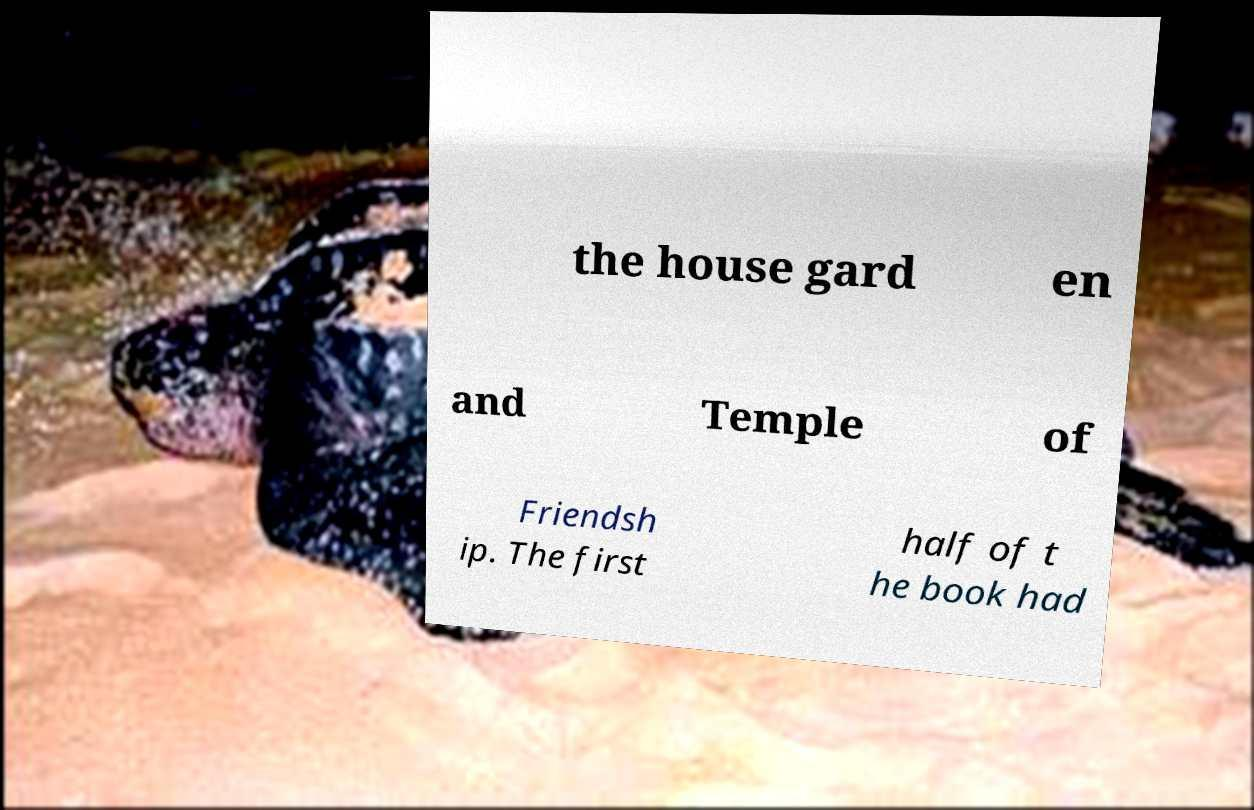There's text embedded in this image that I need extracted. Can you transcribe it verbatim? the house gard en and Temple of Friendsh ip. The first half of t he book had 